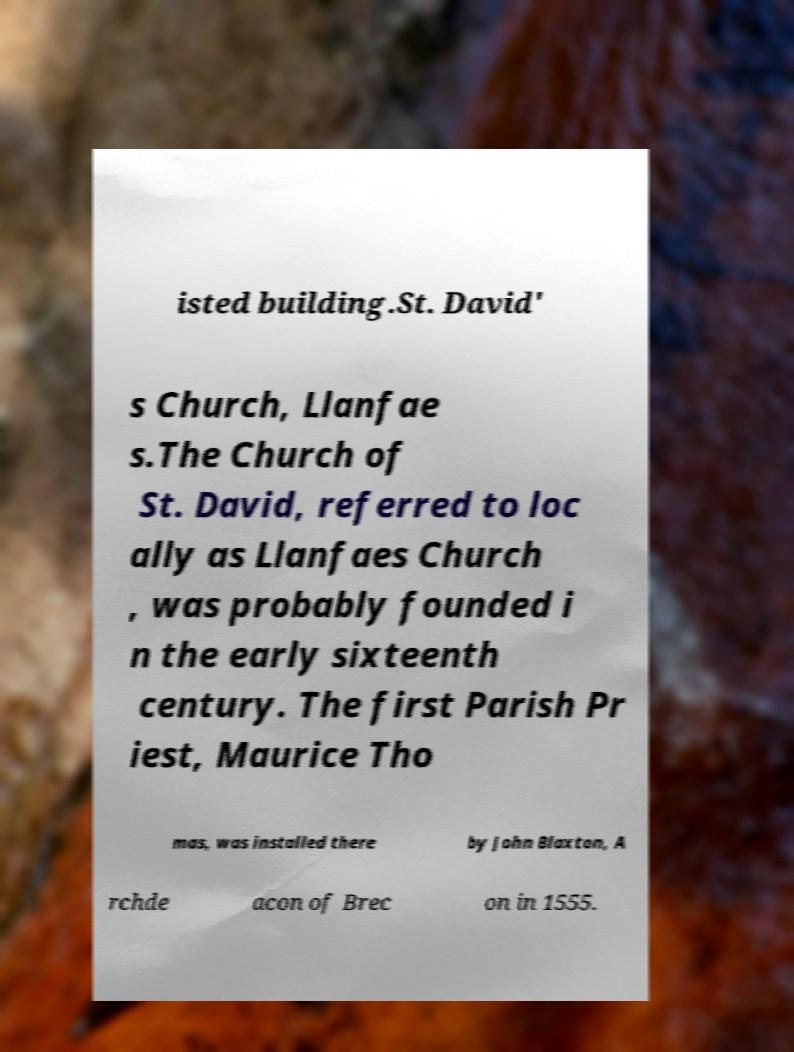Can you accurately transcribe the text from the provided image for me? isted building.St. David' s Church, Llanfae s.The Church of St. David, referred to loc ally as Llanfaes Church , was probably founded i n the early sixteenth century. The first Parish Pr iest, Maurice Tho mas, was installed there by John Blaxton, A rchde acon of Brec on in 1555. 